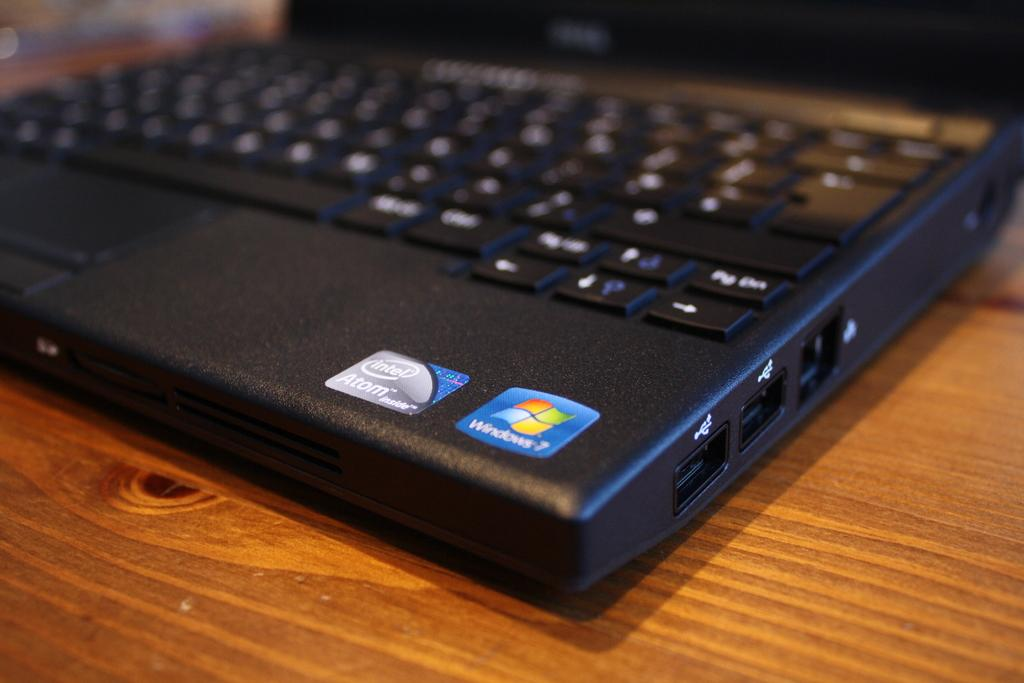<image>
Render a clear and concise summary of the photo. An open laptop with Intel and Windows 7 stickers near the bottom of the keyboard. 